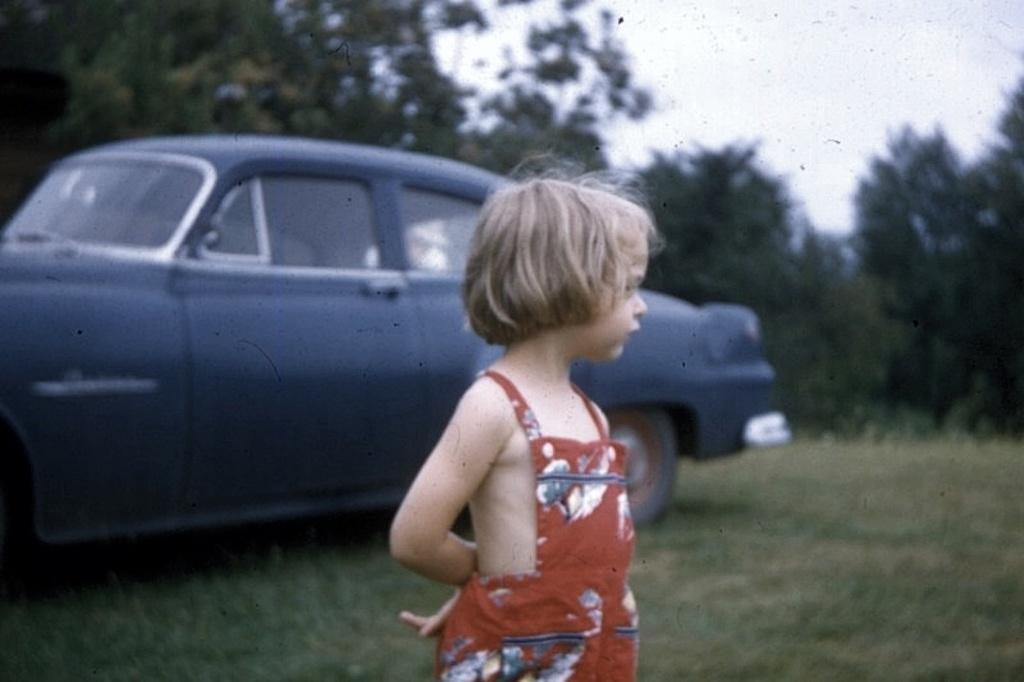What is the main subject of the image? The main subject of the image is a kid. What is the kid wearing? The kid is wearing a red dress. What is the ground like where the kid is standing? The kid is standing on a greenery ground. What can be seen behind the kid? There is a car behind the kid. What is visible in the background of the image? There are trees in the background of the image. What type of sign can be seen in the image? There is no sign present in the image. What is the kid's argument about in the image? The image does not depict a situation where the kid is making an argument; it simply shows the kid standing on a greenery ground. 